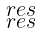<formula> <loc_0><loc_0><loc_500><loc_500>\begin{smallmatrix} \ r e s \\ \ r e s \end{smallmatrix}</formula> 